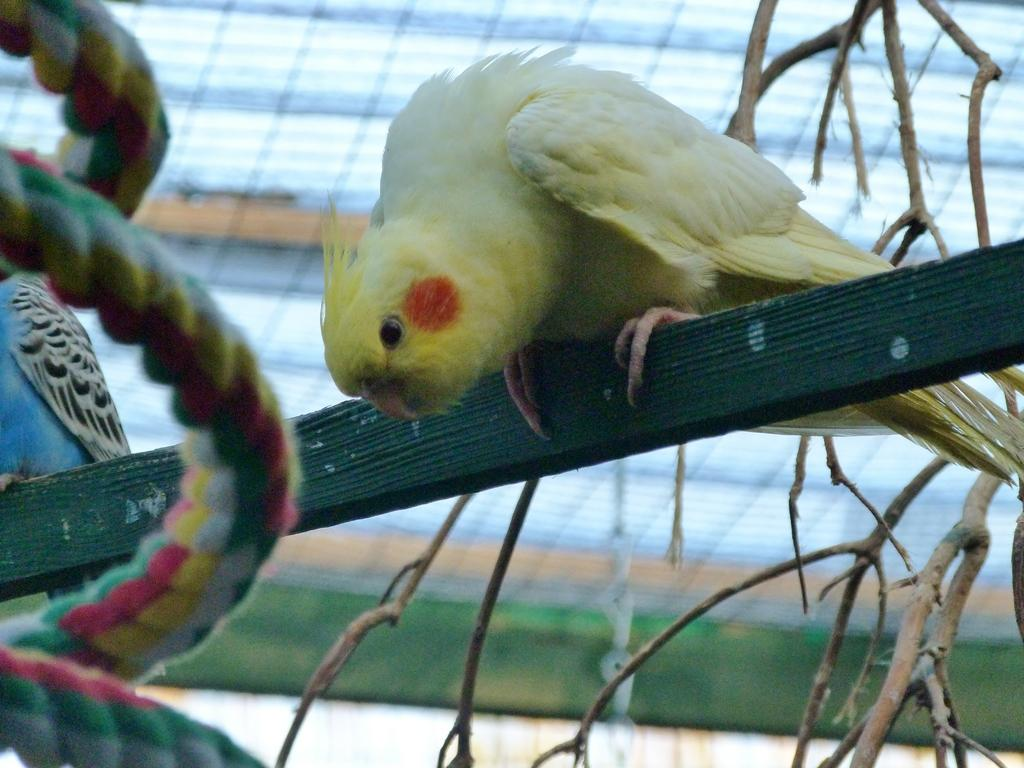What type of animals can be seen in the image? There are birds in the image. Where are the birds located? The birds are on a wood stick in the image. What other objects can be seen in the image? There is a rope and a stem in the image. How many quivers can be seen in the image? There are no quivers present in the image. What color are the birds' toes in the image? The image does not show the birds' toes, so it cannot be determined what color they are. 